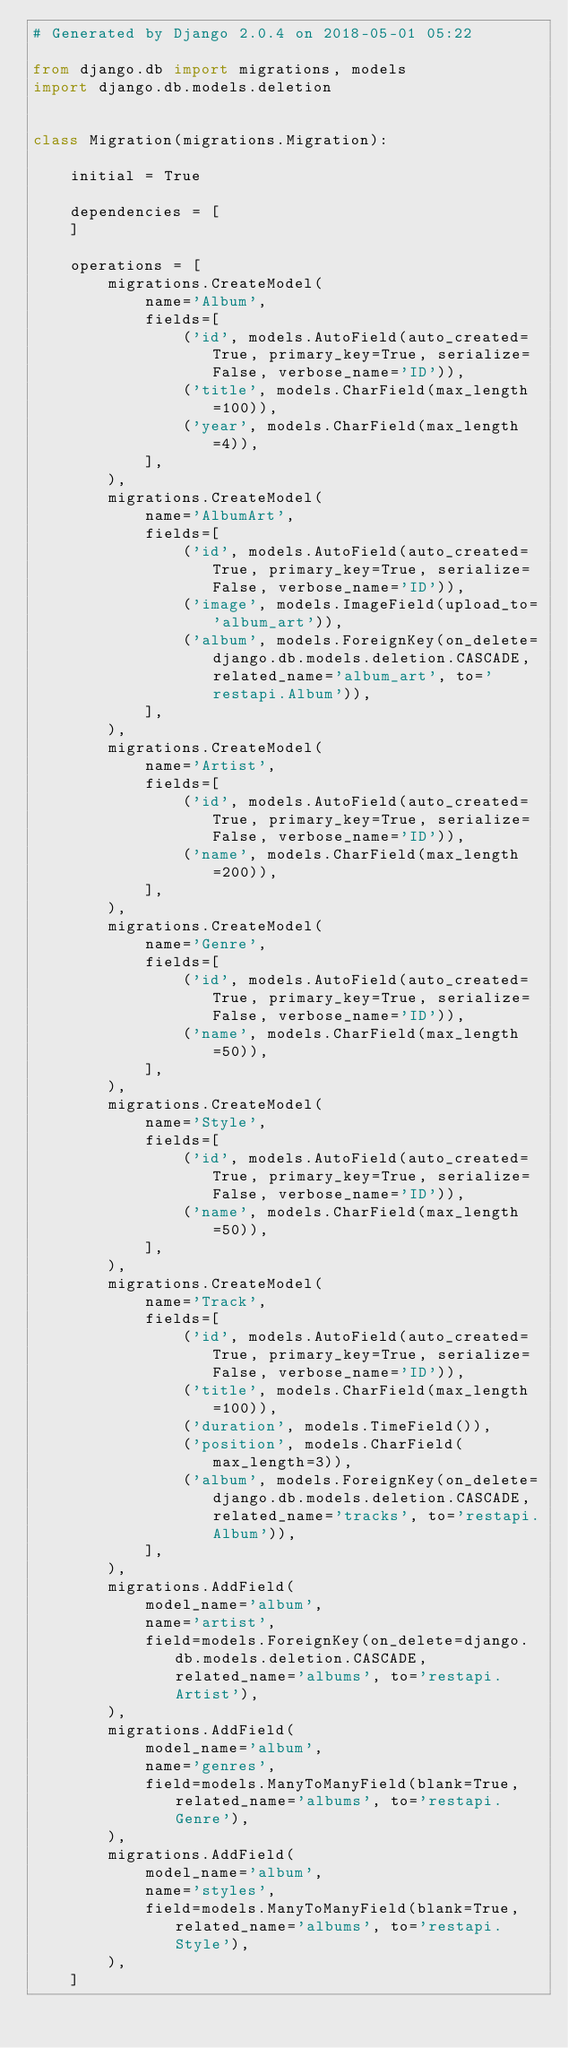<code> <loc_0><loc_0><loc_500><loc_500><_Python_># Generated by Django 2.0.4 on 2018-05-01 05:22

from django.db import migrations, models
import django.db.models.deletion


class Migration(migrations.Migration):

    initial = True

    dependencies = [
    ]

    operations = [
        migrations.CreateModel(
            name='Album',
            fields=[
                ('id', models.AutoField(auto_created=True, primary_key=True, serialize=False, verbose_name='ID')),
                ('title', models.CharField(max_length=100)),
                ('year', models.CharField(max_length=4)),
            ],
        ),
        migrations.CreateModel(
            name='AlbumArt',
            fields=[
                ('id', models.AutoField(auto_created=True, primary_key=True, serialize=False, verbose_name='ID')),
                ('image', models.ImageField(upload_to='album_art')),
                ('album', models.ForeignKey(on_delete=django.db.models.deletion.CASCADE, related_name='album_art', to='restapi.Album')),
            ],
        ),
        migrations.CreateModel(
            name='Artist',
            fields=[
                ('id', models.AutoField(auto_created=True, primary_key=True, serialize=False, verbose_name='ID')),
                ('name', models.CharField(max_length=200)),
            ],
        ),
        migrations.CreateModel(
            name='Genre',
            fields=[
                ('id', models.AutoField(auto_created=True, primary_key=True, serialize=False, verbose_name='ID')),
                ('name', models.CharField(max_length=50)),
            ],
        ),
        migrations.CreateModel(
            name='Style',
            fields=[
                ('id', models.AutoField(auto_created=True, primary_key=True, serialize=False, verbose_name='ID')),
                ('name', models.CharField(max_length=50)),
            ],
        ),
        migrations.CreateModel(
            name='Track',
            fields=[
                ('id', models.AutoField(auto_created=True, primary_key=True, serialize=False, verbose_name='ID')),
                ('title', models.CharField(max_length=100)),
                ('duration', models.TimeField()),
                ('position', models.CharField(max_length=3)),
                ('album', models.ForeignKey(on_delete=django.db.models.deletion.CASCADE, related_name='tracks', to='restapi.Album')),
            ],
        ),
        migrations.AddField(
            model_name='album',
            name='artist',
            field=models.ForeignKey(on_delete=django.db.models.deletion.CASCADE, related_name='albums', to='restapi.Artist'),
        ),
        migrations.AddField(
            model_name='album',
            name='genres',
            field=models.ManyToManyField(blank=True, related_name='albums', to='restapi.Genre'),
        ),
        migrations.AddField(
            model_name='album',
            name='styles',
            field=models.ManyToManyField(blank=True, related_name='albums', to='restapi.Style'),
        ),
    ]
</code> 